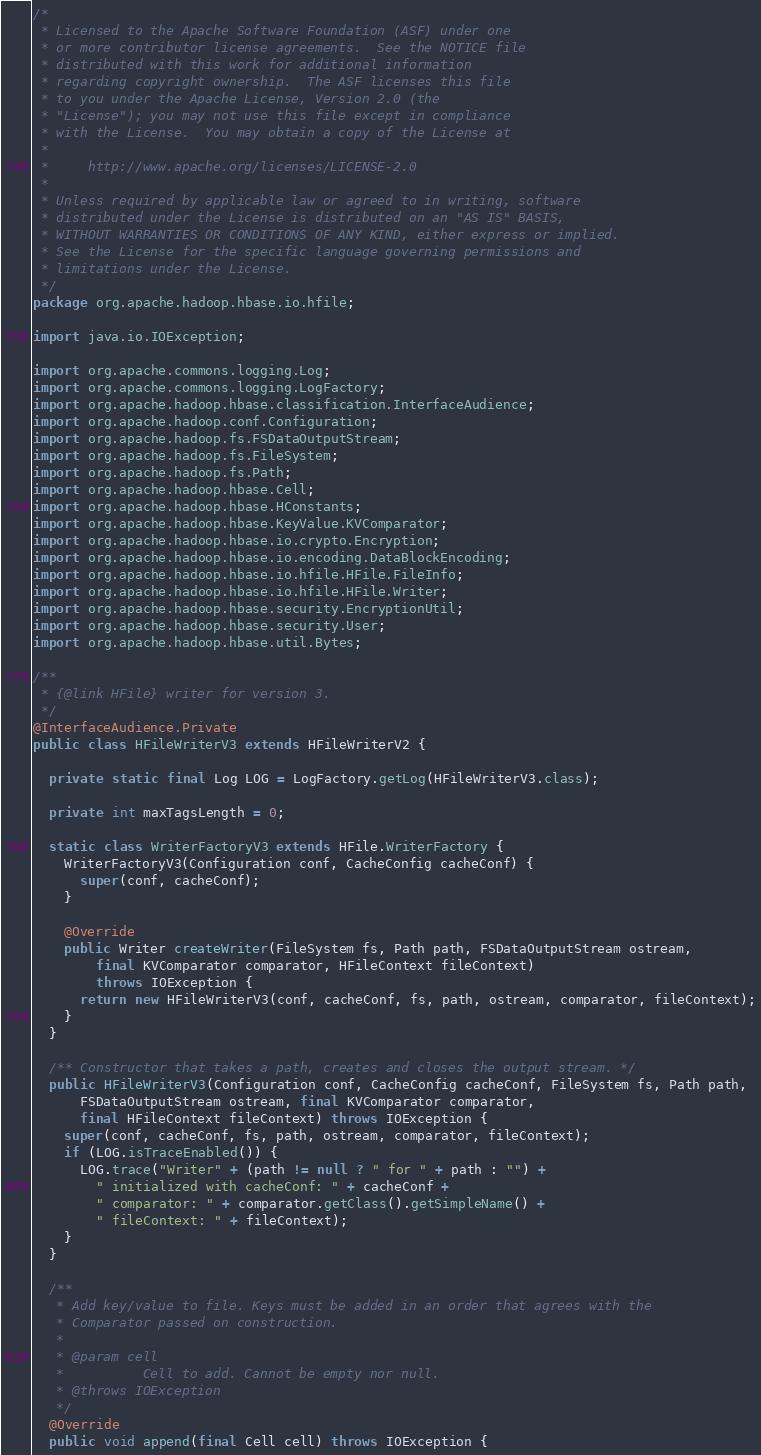<code> <loc_0><loc_0><loc_500><loc_500><_Java_>/*
 * Licensed to the Apache Software Foundation (ASF) under one
 * or more contributor license agreements.  See the NOTICE file
 * distributed with this work for additional information
 * regarding copyright ownership.  The ASF licenses this file
 * to you under the Apache License, Version 2.0 (the
 * "License"); you may not use this file except in compliance
 * with the License.  You may obtain a copy of the License at
 *
 *     http://www.apache.org/licenses/LICENSE-2.0
 *
 * Unless required by applicable law or agreed to in writing, software
 * distributed under the License is distributed on an "AS IS" BASIS,
 * WITHOUT WARRANTIES OR CONDITIONS OF ANY KIND, either express or implied.
 * See the License for the specific language governing permissions and
 * limitations under the License.
 */
package org.apache.hadoop.hbase.io.hfile;

import java.io.IOException;

import org.apache.commons.logging.Log;
import org.apache.commons.logging.LogFactory;
import org.apache.hadoop.hbase.classification.InterfaceAudience;
import org.apache.hadoop.conf.Configuration;
import org.apache.hadoop.fs.FSDataOutputStream;
import org.apache.hadoop.fs.FileSystem;
import org.apache.hadoop.fs.Path;
import org.apache.hadoop.hbase.Cell;
import org.apache.hadoop.hbase.HConstants;
import org.apache.hadoop.hbase.KeyValue.KVComparator;
import org.apache.hadoop.hbase.io.crypto.Encryption;
import org.apache.hadoop.hbase.io.encoding.DataBlockEncoding;
import org.apache.hadoop.hbase.io.hfile.HFile.FileInfo;
import org.apache.hadoop.hbase.io.hfile.HFile.Writer;
import org.apache.hadoop.hbase.security.EncryptionUtil;
import org.apache.hadoop.hbase.security.User;
import org.apache.hadoop.hbase.util.Bytes;

/**
 * {@link HFile} writer for version 3.
 */
@InterfaceAudience.Private
public class HFileWriterV3 extends HFileWriterV2 {

  private static final Log LOG = LogFactory.getLog(HFileWriterV3.class);

  private int maxTagsLength = 0;

  static class WriterFactoryV3 extends HFile.WriterFactory {
    WriterFactoryV3(Configuration conf, CacheConfig cacheConf) {
      super(conf, cacheConf);
    }

    @Override
    public Writer createWriter(FileSystem fs, Path path, FSDataOutputStream ostream,
        final KVComparator comparator, HFileContext fileContext)
        throws IOException {
      return new HFileWriterV3(conf, cacheConf, fs, path, ostream, comparator, fileContext);
    }
  }

  /** Constructor that takes a path, creates and closes the output stream. */
  public HFileWriterV3(Configuration conf, CacheConfig cacheConf, FileSystem fs, Path path,
      FSDataOutputStream ostream, final KVComparator comparator,
      final HFileContext fileContext) throws IOException {
    super(conf, cacheConf, fs, path, ostream, comparator, fileContext);
    if (LOG.isTraceEnabled()) {
      LOG.trace("Writer" + (path != null ? " for " + path : "") +
        " initialized with cacheConf: " + cacheConf +
        " comparator: " + comparator.getClass().getSimpleName() +
        " fileContext: " + fileContext);
    }
  }

  /**
   * Add key/value to file. Keys must be added in an order that agrees with the
   * Comparator passed on construction.
   * 
   * @param cell
   *          Cell to add. Cannot be empty nor null.
   * @throws IOException
   */
  @Override
  public void append(final Cell cell) throws IOException {</code> 